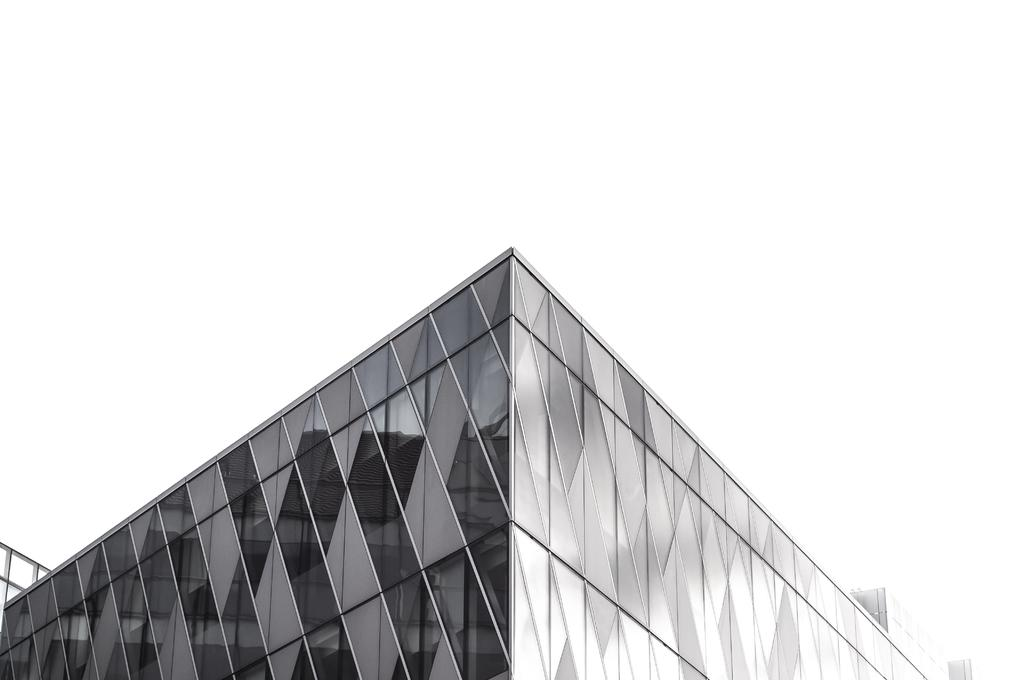What is the color scheme of the image? The image is black and white. Where was the image taken? The image was taken outdoors. What can be seen in the background of the image? There is a building in the image. What type of lace can be seen on the building in the image? There is no lace visible on the building in the image, as it is a black and white photograph. 